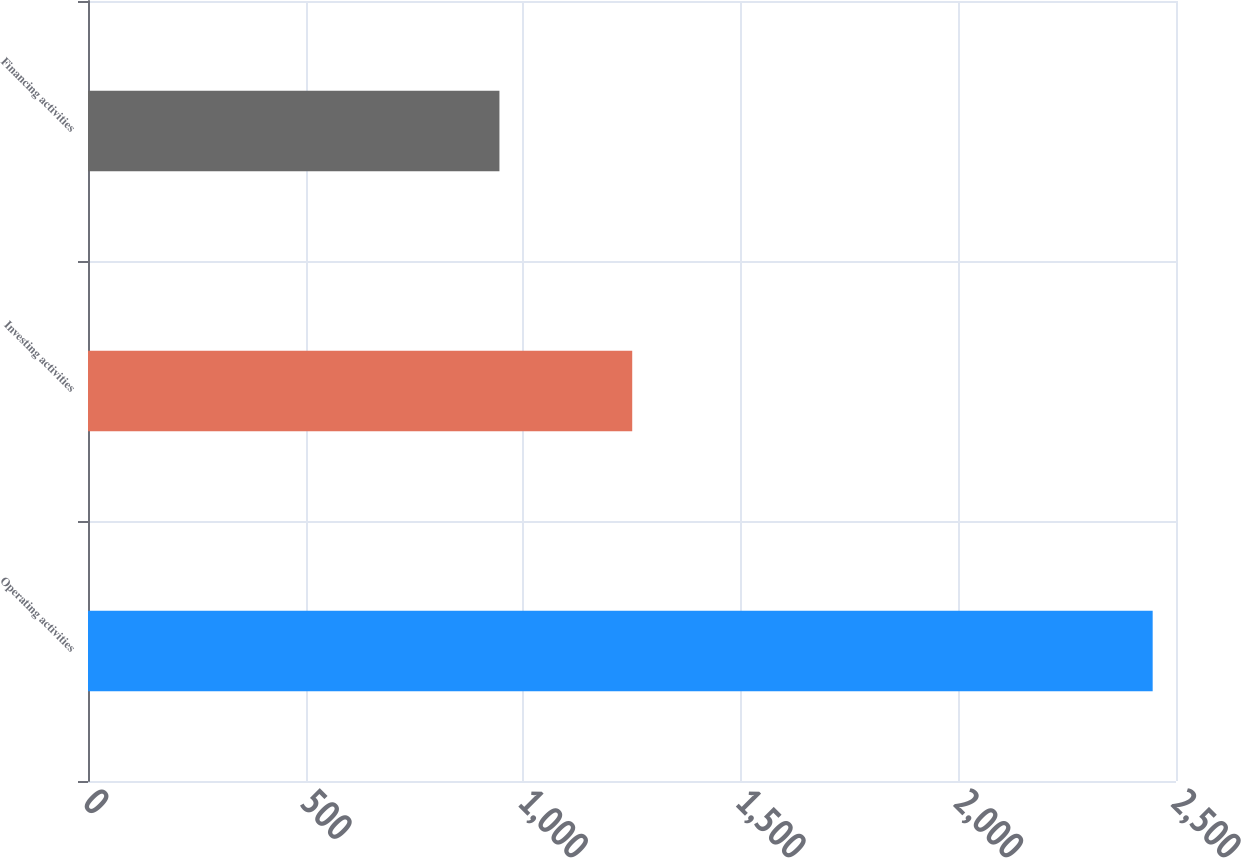Convert chart to OTSL. <chart><loc_0><loc_0><loc_500><loc_500><bar_chart><fcel>Operating activities<fcel>Investing activities<fcel>Financing activities<nl><fcel>2446.4<fcel>1250.5<fcel>945.4<nl></chart> 